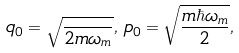<formula> <loc_0><loc_0><loc_500><loc_500>q _ { 0 } = \sqrt { \frac { } { 2 m \omega _ { m } } } , \, p _ { 0 } = \sqrt { \frac { m \hbar { \omega } _ { m } } { 2 } } ,</formula> 